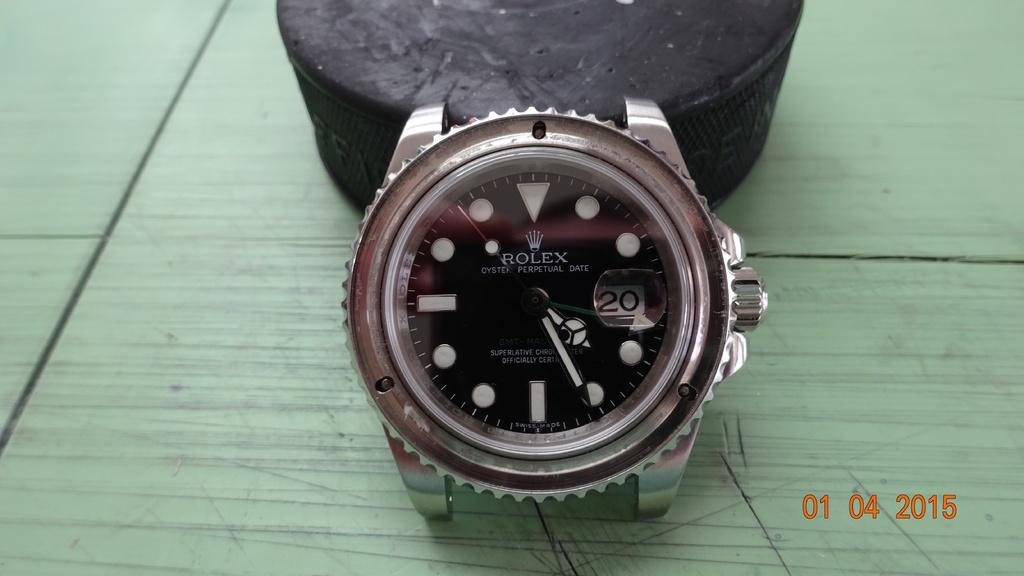<image>
Summarize the visual content of the image. A Rolex watch shows the time of 4:26 and the date of the 20th. 